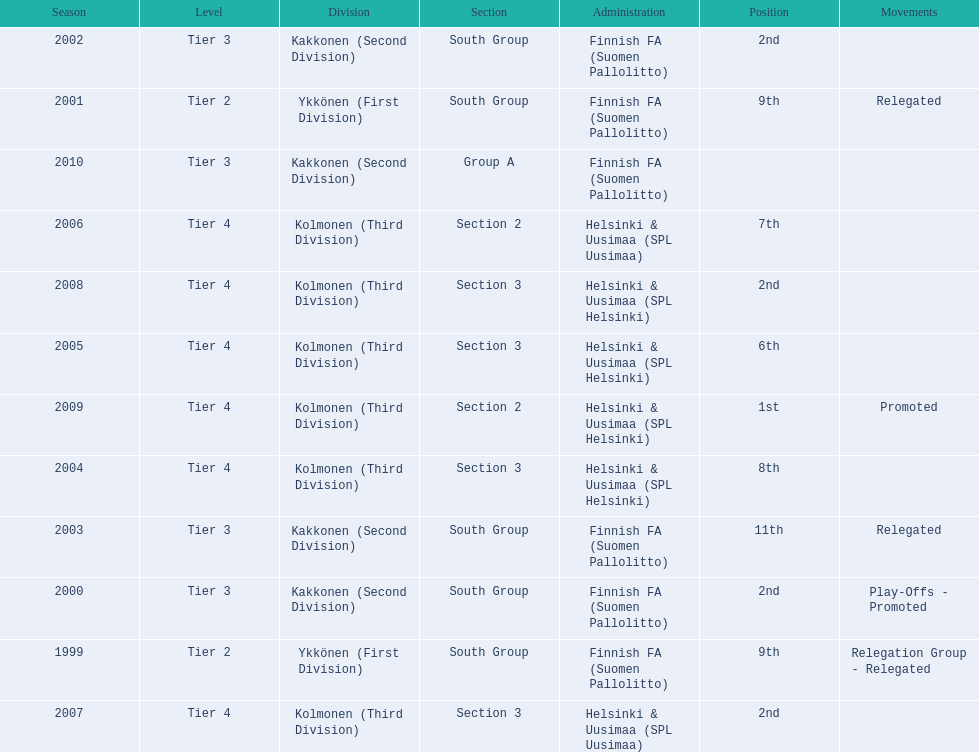How many tiers had more than one relegated movement? 1. 